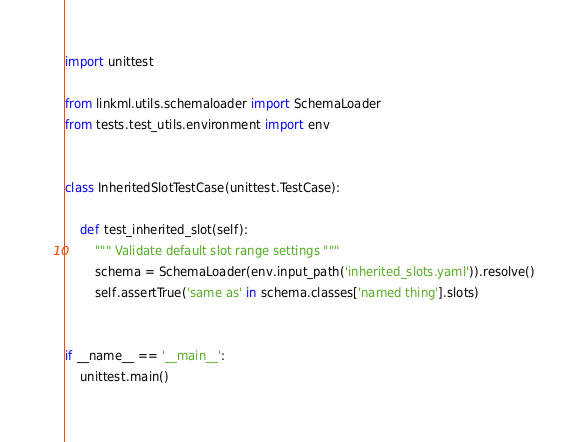Convert code to text. <code><loc_0><loc_0><loc_500><loc_500><_Python_>import unittest

from linkml.utils.schemaloader import SchemaLoader
from tests.test_utils.environment import env


class InheritedSlotTestCase(unittest.TestCase):

    def test_inherited_slot(self):
        """ Validate default slot range settings """
        schema = SchemaLoader(env.input_path('inherited_slots.yaml')).resolve()
        self.assertTrue('same as' in schema.classes['named thing'].slots)


if __name__ == '__main__':
    unittest.main()
</code> 